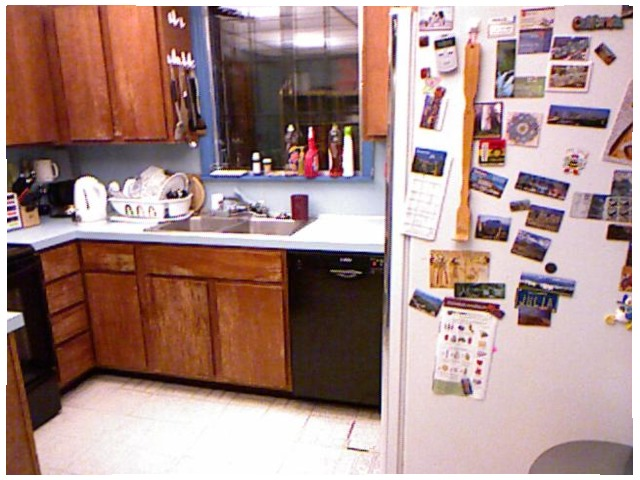<image>
Is the back scratcher on the fridge? Yes. Looking at the image, I can see the back scratcher is positioned on top of the fridge, with the fridge providing support. Is the paper on the table? No. The paper is not positioned on the table. They may be near each other, but the paper is not supported by or resting on top of the table. Is the sink next to the dishes? Yes. The sink is positioned adjacent to the dishes, located nearby in the same general area. 